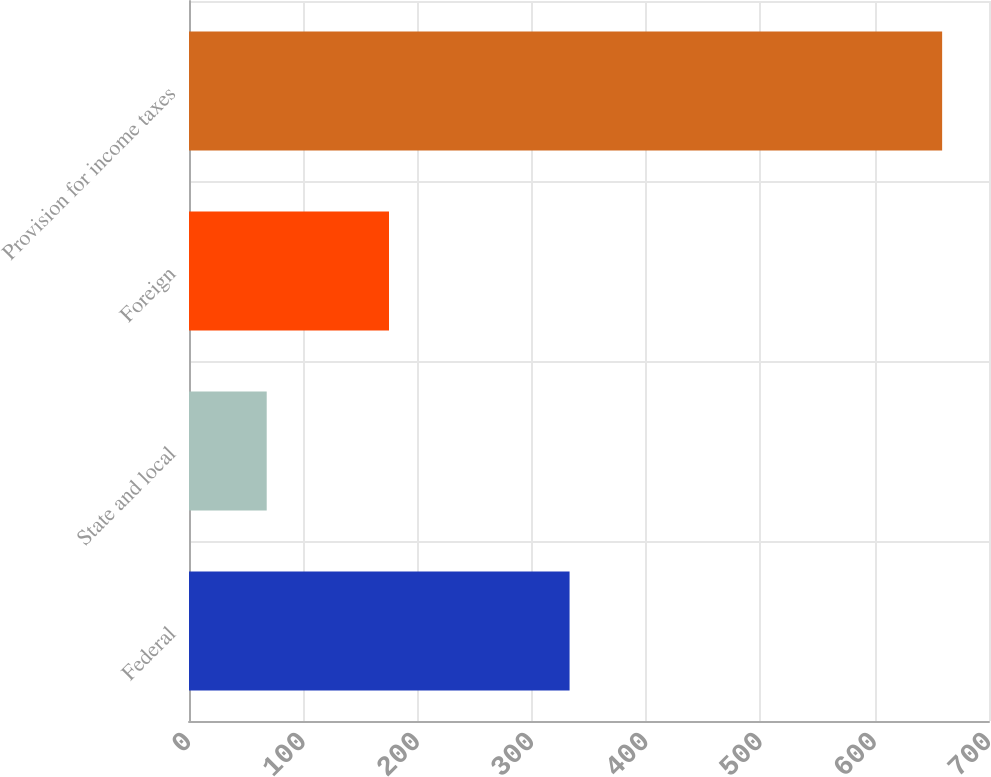Convert chart to OTSL. <chart><loc_0><loc_0><loc_500><loc_500><bar_chart><fcel>Federal<fcel>State and local<fcel>Foreign<fcel>Provision for income taxes<nl><fcel>333<fcel>68<fcel>175<fcel>659<nl></chart> 